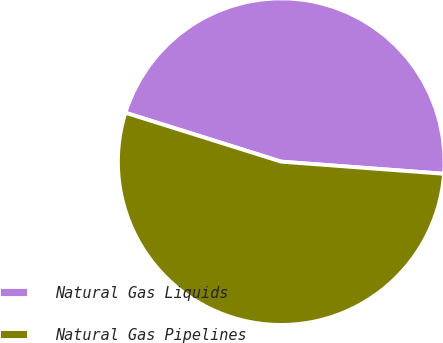Convert chart. <chart><loc_0><loc_0><loc_500><loc_500><pie_chart><fcel>Natural Gas Liquids<fcel>Natural Gas Pipelines<nl><fcel>46.34%<fcel>53.66%<nl></chart> 